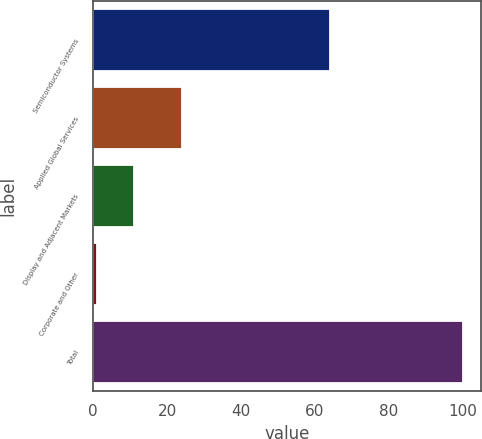Convert chart. <chart><loc_0><loc_0><loc_500><loc_500><bar_chart><fcel>Semiconductor Systems<fcel>Applied Global Services<fcel>Display and Adjacent Markets<fcel>Corporate and Other<fcel>Total<nl><fcel>64<fcel>24<fcel>11<fcel>1<fcel>100<nl></chart> 